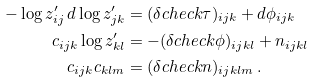<formula> <loc_0><loc_0><loc_500><loc_500>- \log z ^ { \prime } _ { i j } \, d \log z ^ { \prime } _ { j k } & = ( \delta c h e c k \tau ) _ { i j k } + d \phi _ { i j k } \\ c _ { i j k } \log z ^ { \prime } _ { k l } & = - ( \delta c h e c k \phi ) _ { i j k l } + n _ { i j k l } \\ c _ { i j k } c _ { k l m } & = ( \delta c h e c k n ) _ { i j k l m } \, .</formula> 